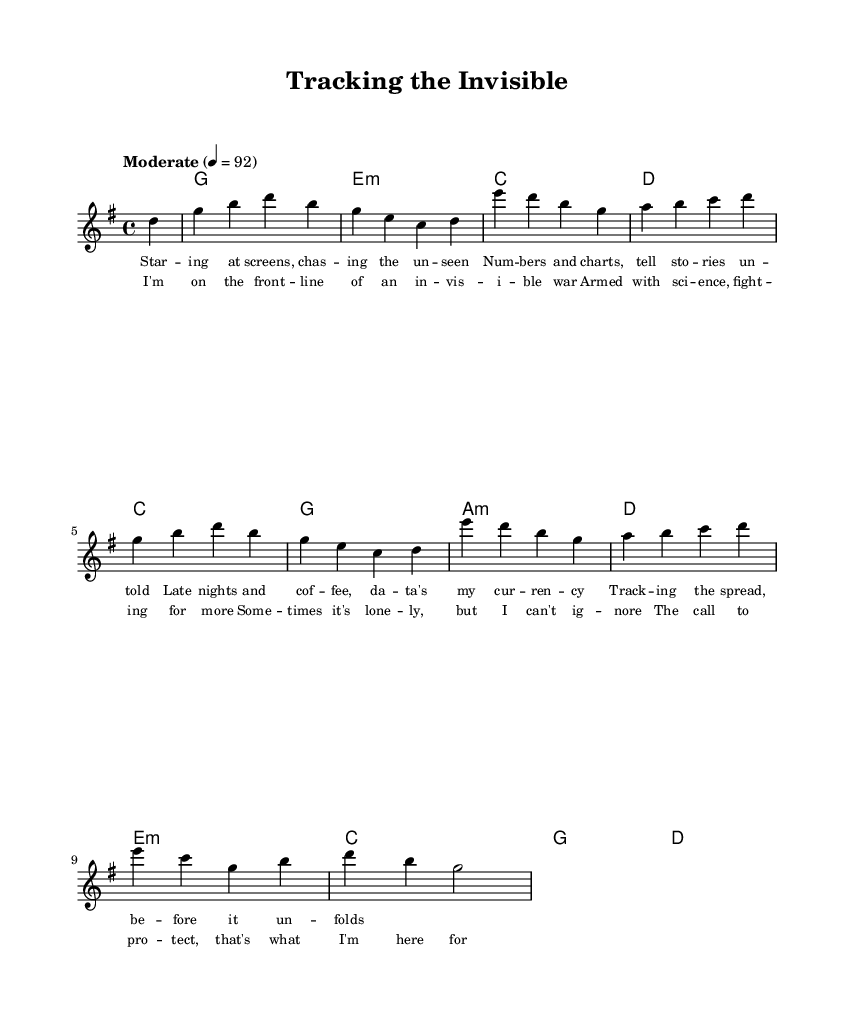What is the key signature of this music? The key signature is G major, which has one sharp (F#). This can be identified by examining the key signature indicated at the beginning of the score.
Answer: G major What is the tempo marking? The tempo marking is "Moderate" with a speed of 92 beats per minute. This is specified in the tempo notation within the score indicating the desired speed of the piece.
Answer: Moderate 4 = 92 What is the time signature? The time signature is 4/4. This means there are four beats in each measure, which is denoted at the start of the sheet music.
Answer: 4/4 How many measures are there in the melody? There are 10 measures in the melody, which can be counted by examining the horizontal lines separating the musical phrases in the score.
Answer: 10 What is the predominant theme of the lyrics? The predominant theme of the lyrics focuses on public health, specifically the challenges and rewards faced in this field. This is evident through the imagery and context described in the lyrics.
Answer: Public health Which chord is associated with the first measure? The first measure is associated with a G major chord, indicated in the chord names section at the beginning of the music. This chord name is provided above the staff where the melody is written.
Answer: G What role does the chorus play in this piece? The chorus serves as a central emotional statement, emphasizing determination and purpose in the face of challenges in public health. This can be concluded from its position in the structure of the song and lyrical content.
Answer: Central emotional statement 